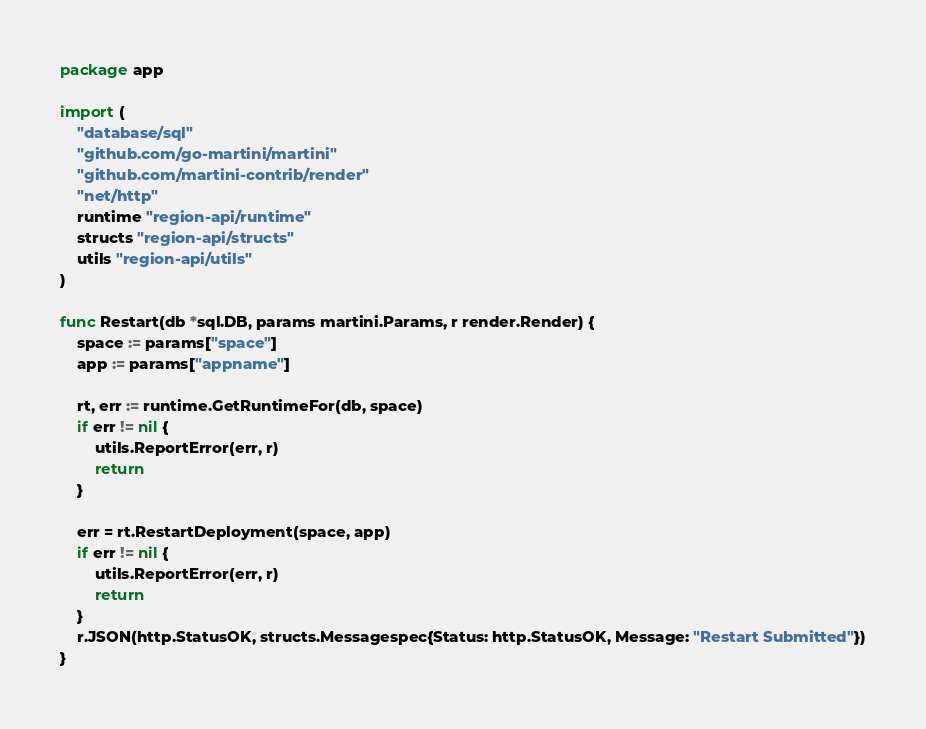<code> <loc_0><loc_0><loc_500><loc_500><_Go_>package app

import (
	"database/sql"
	"github.com/go-martini/martini"
	"github.com/martini-contrib/render"
	"net/http"
	runtime "region-api/runtime"
	structs "region-api/structs"
	utils "region-api/utils"
)

func Restart(db *sql.DB, params martini.Params, r render.Render) {
	space := params["space"]
	app := params["appname"]

	rt, err := runtime.GetRuntimeFor(db, space)
	if err != nil {
		utils.ReportError(err, r)
		return
	}

	err = rt.RestartDeployment(space, app)
	if err != nil {
		utils.ReportError(err, r)
		return
	}
	r.JSON(http.StatusOK, structs.Messagespec{Status: http.StatusOK, Message: "Restart Submitted"})
}
</code> 